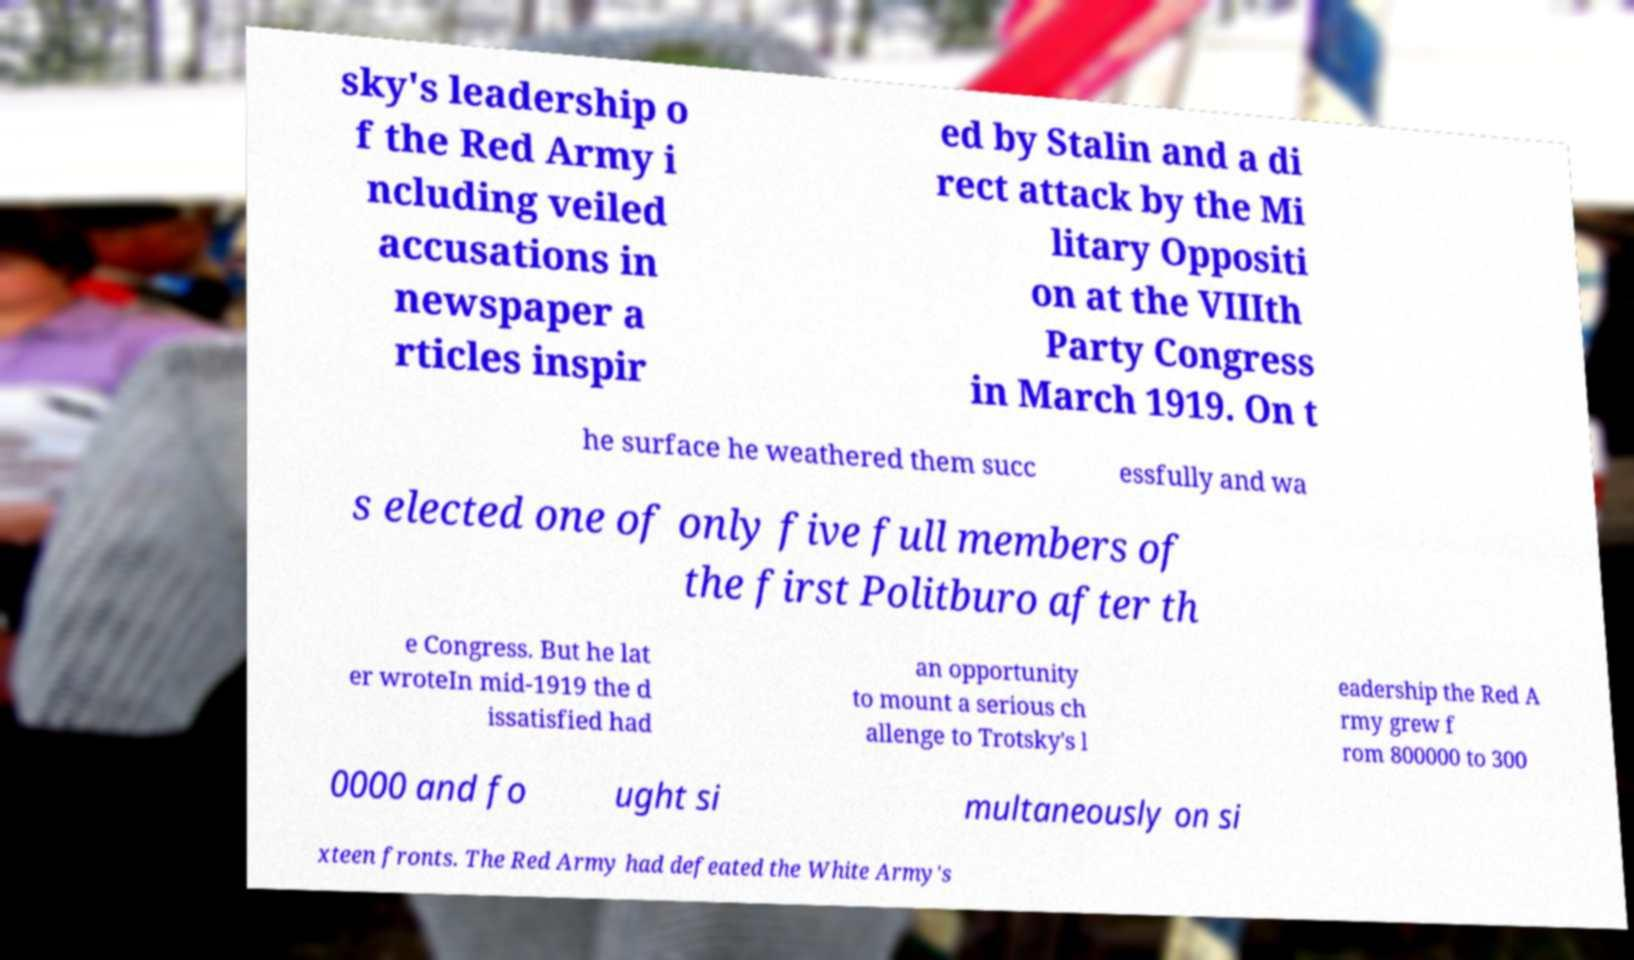There's text embedded in this image that I need extracted. Can you transcribe it verbatim? sky's leadership o f the Red Army i ncluding veiled accusations in newspaper a rticles inspir ed by Stalin and a di rect attack by the Mi litary Oppositi on at the VIIIth Party Congress in March 1919. On t he surface he weathered them succ essfully and wa s elected one of only five full members of the first Politburo after th e Congress. But he lat er wroteIn mid-1919 the d issatisfied had an opportunity to mount a serious ch allenge to Trotsky's l eadership the Red A rmy grew f rom 800000 to 300 0000 and fo ught si multaneously on si xteen fronts. The Red Army had defeated the White Army's 